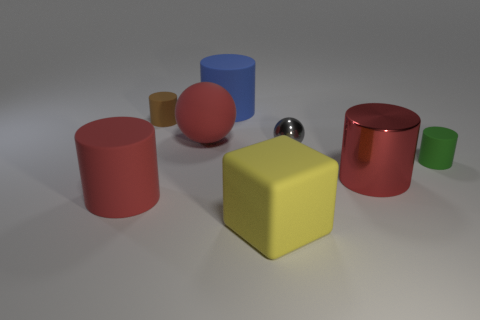There is a cylinder that is in front of the green rubber cylinder and left of the small gray metal thing; what color is it?
Offer a terse response. Red. How many things are big red rubber objects that are to the left of the big red matte sphere or brown matte cylinders on the left side of the small ball?
Keep it short and to the point. 2. The sphere to the right of the big object that is in front of the cylinder on the left side of the brown cylinder is what color?
Your answer should be compact. Gray. Is there a blue metallic thing that has the same shape as the yellow object?
Provide a short and direct response. No. How many small yellow rubber spheres are there?
Make the answer very short. 0. What is the shape of the green matte thing?
Keep it short and to the point. Cylinder. What number of things have the same size as the brown cylinder?
Keep it short and to the point. 2. Does the yellow rubber object have the same shape as the small gray metallic object?
Your response must be concise. No. There is a metal thing that is in front of the gray ball to the right of the tiny brown object; what color is it?
Your answer should be very brief. Red. There is a cylinder that is both left of the green thing and to the right of the matte cube; what size is it?
Provide a short and direct response. Large. 